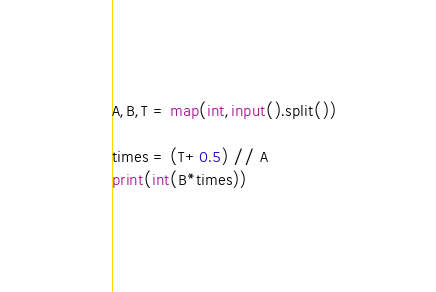<code> <loc_0><loc_0><loc_500><loc_500><_Python_>A,B,T = map(int,input().split())

times = (T+0.5) // A
print(int(B*times))</code> 